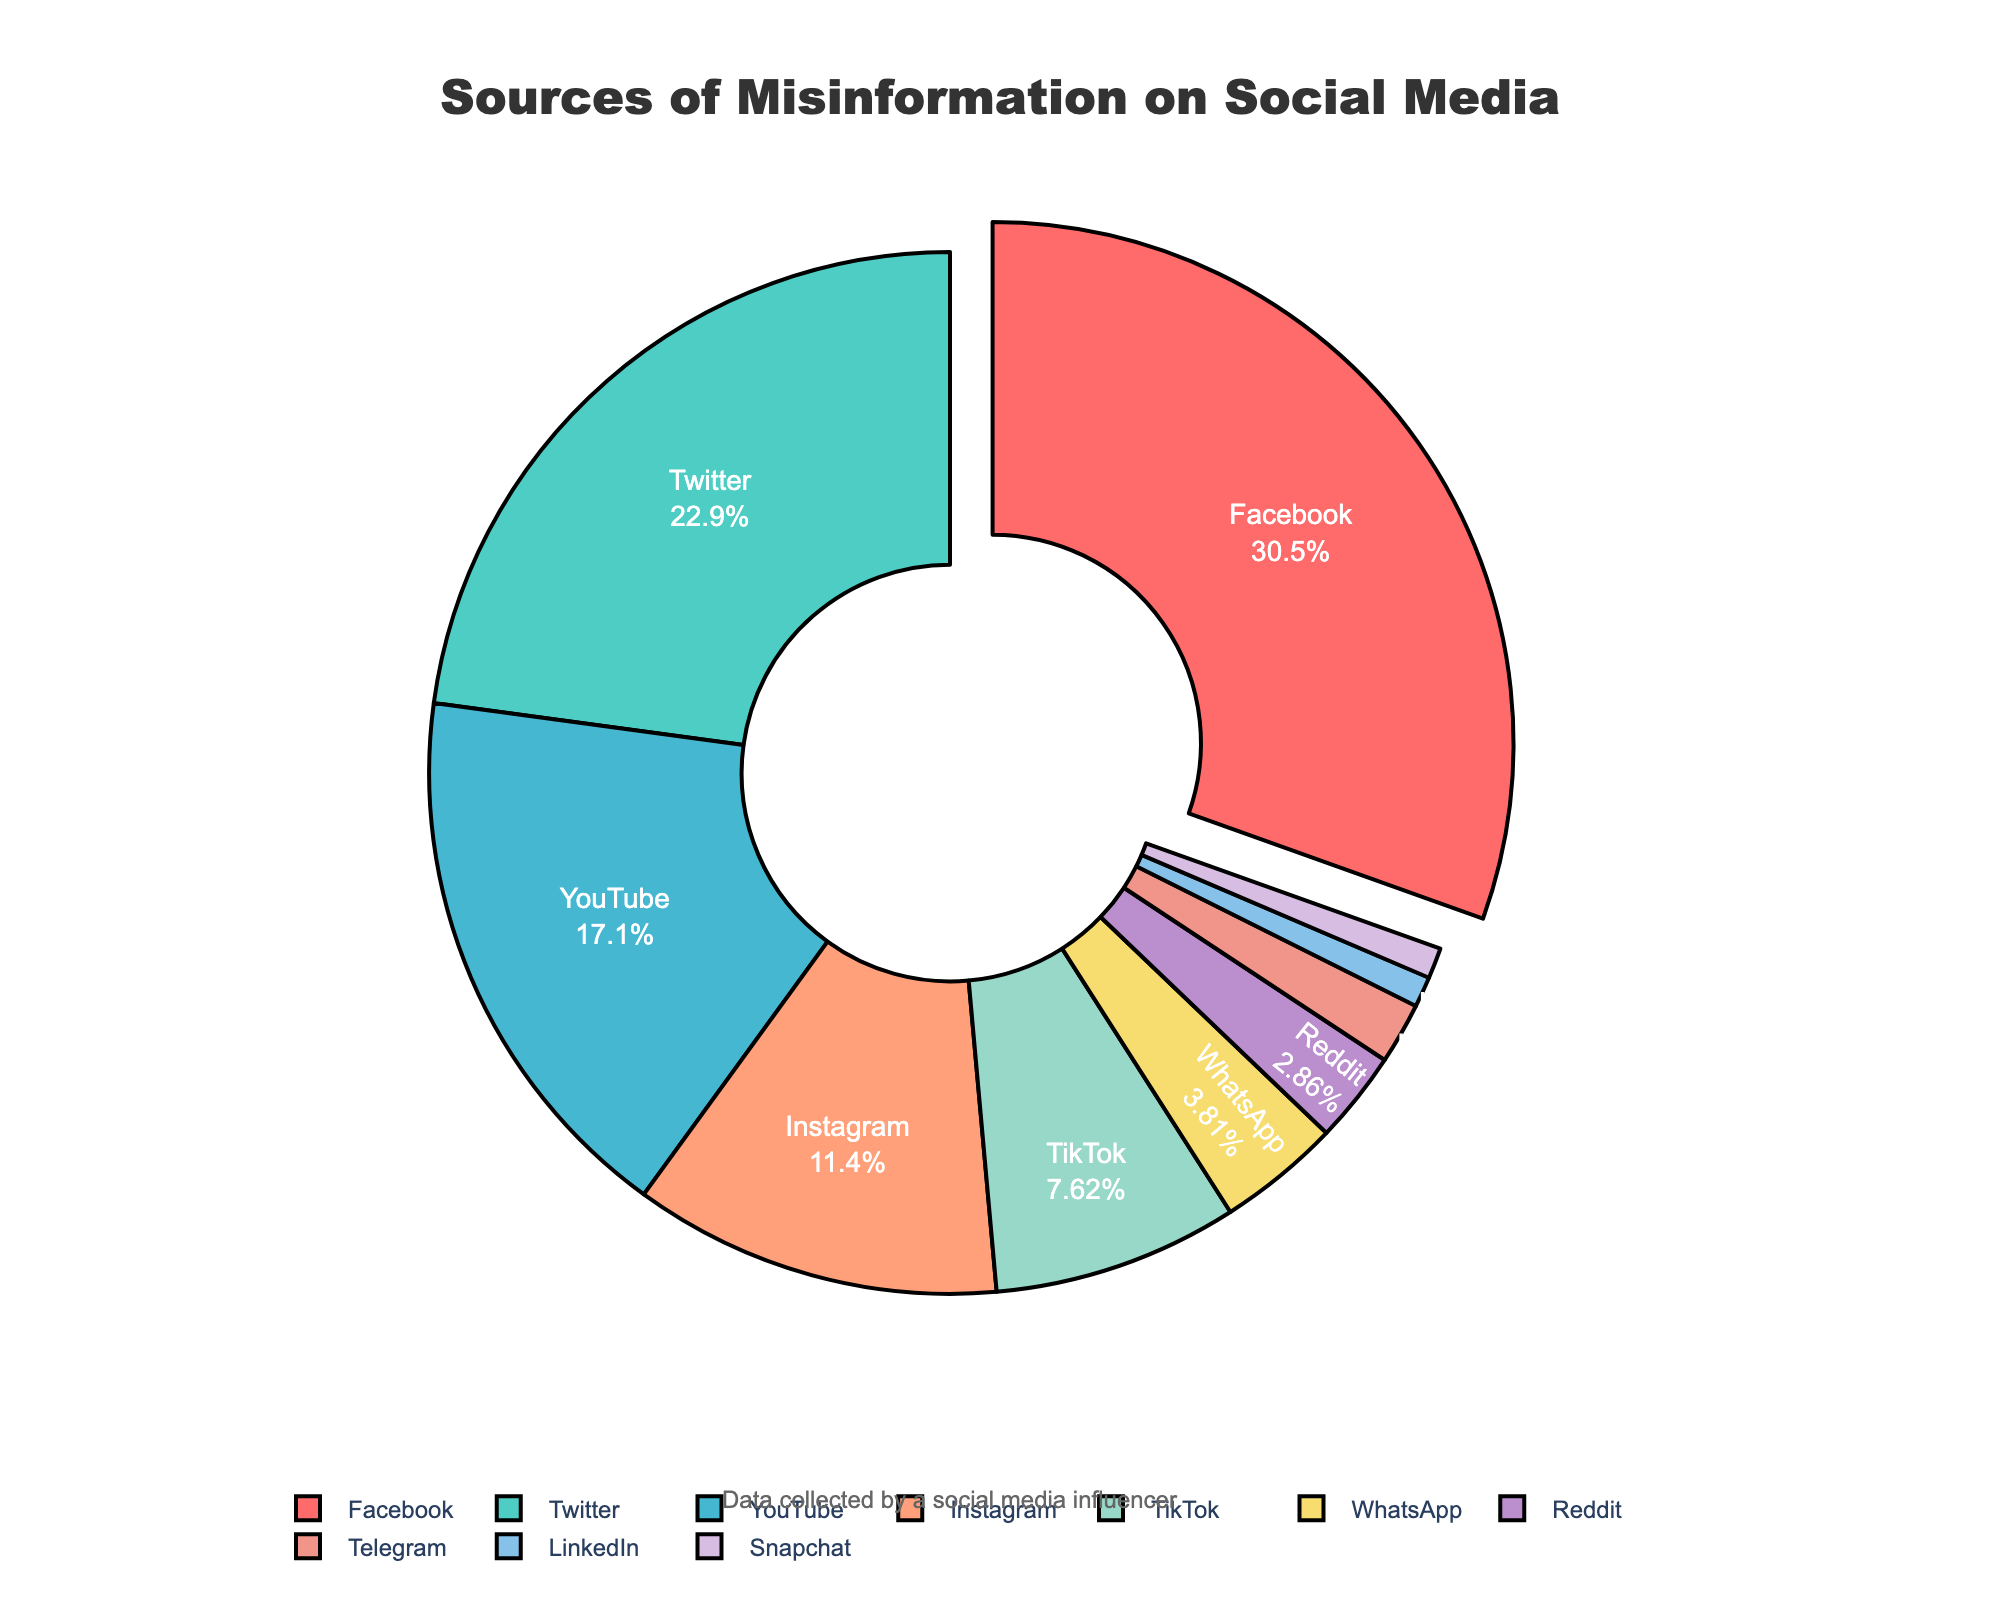what platform accounts for the highest percentage of misinformation? By looking at the pie chart, we can see that Facebook has the largest segment pulled out from the chart, showing its dominance. The label shows it accounts for 32%.
Answer: Facebook what is the combined percentage of misinformation sources from YouTube and Instagram? According to the chart, YouTube accounts for 18% and Instagram accounts for 12%. Adding these together, 18% + 12% = 30%.
Answer: 30% how many platforms account for less than 5% of misinformation sources each? We count the segments representing platforms with less than 5% each: WhatsApp (4%), Reddit (3%), Telegram (2%), LinkedIn (1%), and Snapchat (1%) which adds up to 5 platforms.
Answer: 5 what is the percentage difference between misinformation from Twitter and TikTok? Twitter accounts for 24% and TikTok accounts for 8%. The difference between these percentages is 24% - 8% = 16%.
Answer: 16% which platform has the smallest percentage of misinformation, and what is it? By examining the pie chart, it is clear that LinkedIn and Snapchat each represent the smallest segment, each with 1%.
Answer: LinkedIn and Snapchat, 1% how do the combined percentages of Reddit, Telegram, LinkedIn, and Snapchat compare to Instagram's percentage? Adding the percentages of Reddit (3%), Telegram (2%), LinkedIn (1%), and Snapchat (1%) results in 3% + 2% + 1% + 1% = 7%. Instagram alone has 12%. So, Instagram's percentage is higher.
Answer: Instagram's 12% is higher than the combined 7% which platform's segment is colored red? The pie chart shows that the segment for Facebook is colored red.
Answer: Facebook what is the difference between the percentages of misinformation from Facebook and YouTube? Facebook accounts for 32% and YouTube accounts for 18%. The difference between these percentages is 32% - 18% = 14%.
Answer: 14% name the social media platform with a dark shade of blue in its segment. The dark blue segment corresponds to Twitter.
Answer: Twitter determine the non-primary segment that is pulled out, and its percentage. The only segment pulled out in the pie chart is the primary one, which is Facebook with 32%. No other segments are pulled out.
Answer: Facebook, 32% 